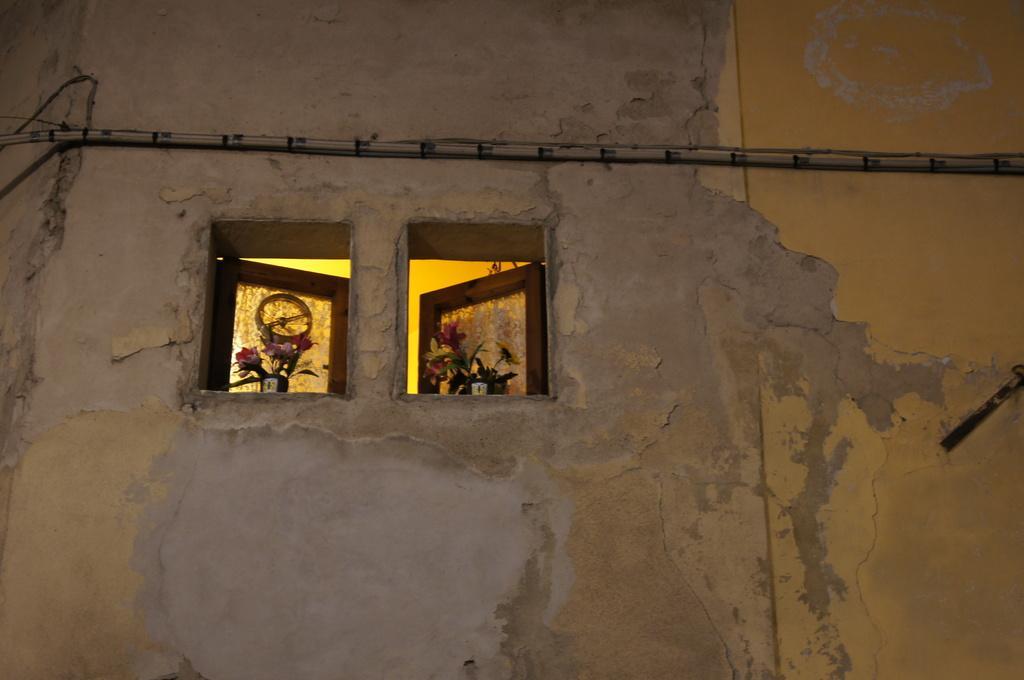Describe this image in one or two sentences. In the picture I can see windows, flowers, a wall and something attached to the wall. 